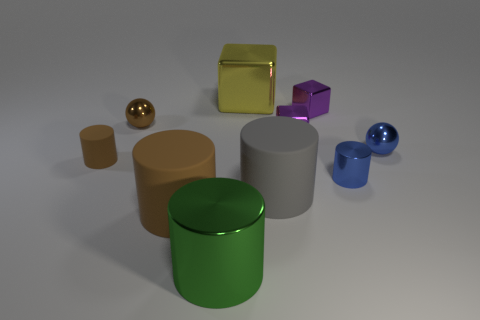Does the small brown rubber object have the same shape as the large brown matte thing?
Offer a very short reply. Yes. There is a cylinder that is the same color as the tiny rubber object; what is it made of?
Provide a short and direct response. Rubber. What is the material of the green thing that is the same size as the yellow cube?
Offer a very short reply. Metal. There is a small shiny object in front of the small brown rubber cylinder; does it have the same color as the ball to the right of the large green shiny cylinder?
Your response must be concise. Yes. What number of red things are metal spheres or shiny cylinders?
Provide a short and direct response. 0. What number of cylinders have the same size as the yellow shiny object?
Make the answer very short. 3. Are the big thing right of the yellow metallic block and the yellow cube made of the same material?
Make the answer very short. No. There is a small ball left of the big metallic cube; is there a tiny thing in front of it?
Your answer should be compact. Yes. There is another object that is the same shape as the small brown shiny object; what is its material?
Make the answer very short. Metal. Are there more blue shiny spheres that are behind the large gray cylinder than big yellow cubes that are on the left side of the yellow thing?
Your answer should be very brief. Yes. 